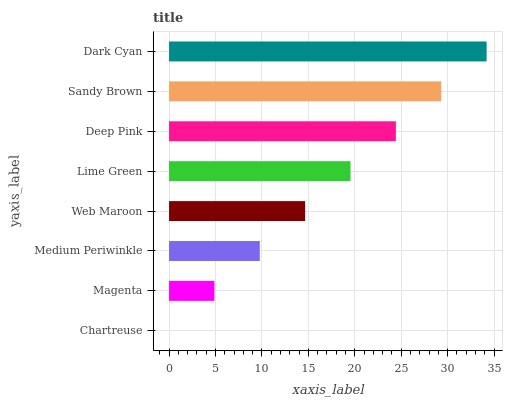Is Chartreuse the minimum?
Answer yes or no. Yes. Is Dark Cyan the maximum?
Answer yes or no. Yes. Is Magenta the minimum?
Answer yes or no. No. Is Magenta the maximum?
Answer yes or no. No. Is Magenta greater than Chartreuse?
Answer yes or no. Yes. Is Chartreuse less than Magenta?
Answer yes or no. Yes. Is Chartreuse greater than Magenta?
Answer yes or no. No. Is Magenta less than Chartreuse?
Answer yes or no. No. Is Lime Green the high median?
Answer yes or no. Yes. Is Web Maroon the low median?
Answer yes or no. Yes. Is Dark Cyan the high median?
Answer yes or no. No. Is Deep Pink the low median?
Answer yes or no. No. 